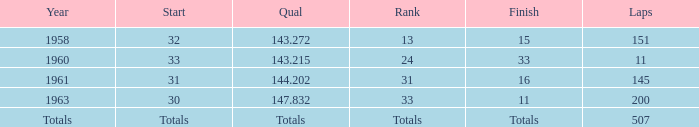What year did the rank of 31 happen in? 1961.0. 